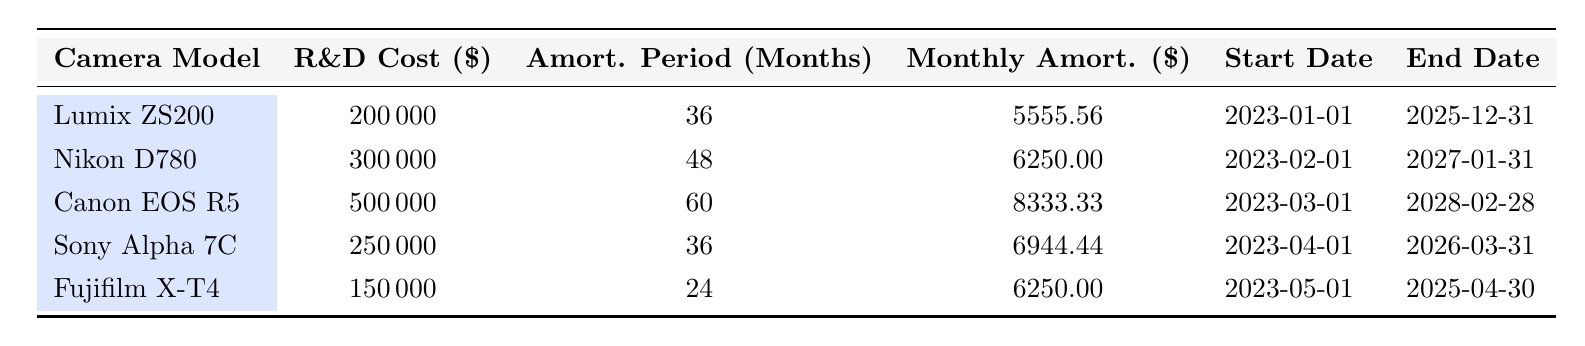What is the R&D cost for the Canon EOS R5? The table explicitly lists the R&D cost for each camera model, and for the Canon EOS R5, it is stated as 500000.
Answer: 500000 Which camera has the longest amortization period? From the table, the amortization periods are as follows: Lumix ZS200 (36 months), Nikon D780 (48 months), Canon EOS R5 (60 months), Sony Alpha 7C (36 months), and Fujifilm X-T4 (24 months). The Canon EOS R5 has the longest period of 60 months.
Answer: Canon EOS R5 Is the monthly amortization for the Lumix ZS200 greater than the Fujifilm X-T4? The monthly amortizations are given as 5555.56 for the Lumix ZS200 and 6250.00 for the Fujifilm X-T4. Since 5555.56 is less than 6250.00, the statement is false.
Answer: No What is the total R&D cost of all the camera models listed? To find the total R&D cost, we sum all the individual costs: 200000 + 300000 + 500000 + 250000 + 150000 = 1400000.
Answer: 1400000 Which two camera models have the same monthly amortization? The table states that the Fujifilm X-T4 and the Nikon D780 both have a monthly amortization of 6250.00. Since this value appears for these two specific models, we can conclude they are the same.
Answer: Fujifilm X-T4, Nikon D780 What is the average monthly amortization across all camera models? To calculate the average, we add the monthly amortizations: 5555.56 + 6250.00 + 8333.33 + 6944.44 + 6250.00 = 35533.33, then divide by the number of models (5): 35533.33 / 5 = 7106.67.
Answer: 7106.67 Is the amortization period longer for the Nikon D780 than the Sony Alpha 7C? The Nikon D780 has an amortization period of 48 months, while the Sony Alpha 7C has an amortization period of 36 months. Since 48 is greater than 36, the statement is true.
Answer: Yes Which camera model's R&D cost is the least? By examining the table, the R&D costs are 200000, 300000, 500000, 250000, and 150000. Therefore, the camera model with the least cost is the Fujifilm X-T4 at 150000.
Answer: Fujifilm X-T4 